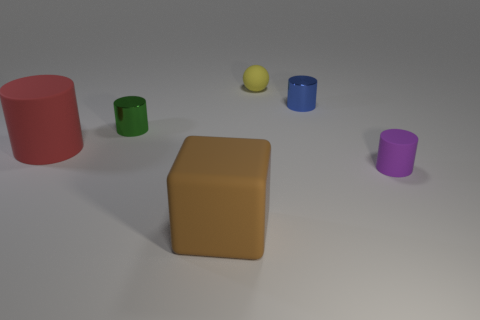Subtract all yellow cylinders. Subtract all gray balls. How many cylinders are left? 4 Add 2 big blue shiny cubes. How many objects exist? 8 Subtract all cubes. How many objects are left? 5 Add 3 small purple rubber things. How many small purple rubber things exist? 4 Subtract 1 blue cylinders. How many objects are left? 5 Subtract all yellow metal things. Subtract all small yellow balls. How many objects are left? 5 Add 4 blue metal objects. How many blue metal objects are left? 5 